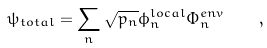Convert formula to latex. <formula><loc_0><loc_0><loc_500><loc_500>\psi _ { t o t a l } = \sum _ { n } { \sqrt { p _ { n } } \phi _ { n } ^ { l o c a l } \Phi _ { n } ^ { e n v } } \quad ,</formula> 